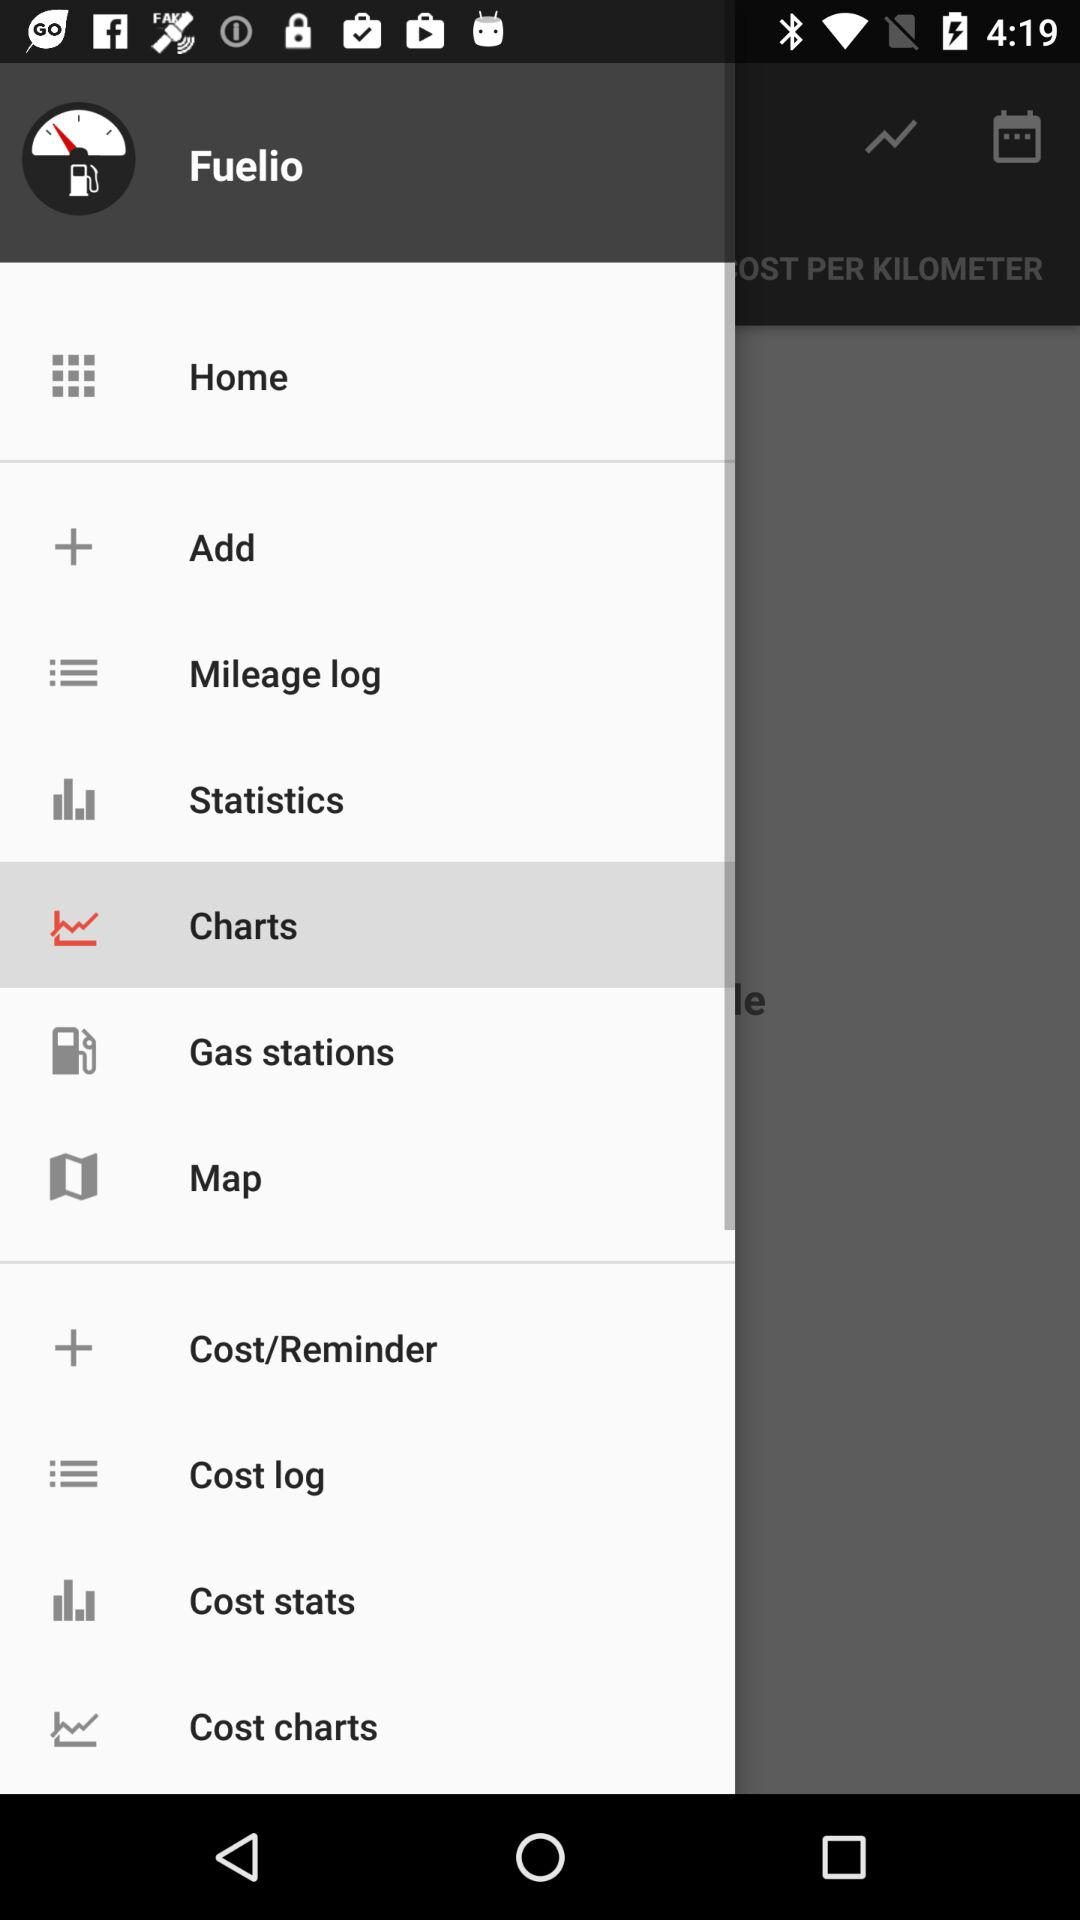What is the name of the application? The name of the application is "Fuelio". 